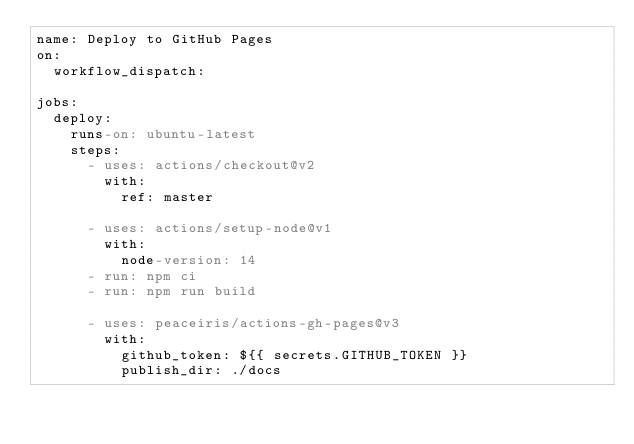Convert code to text. <code><loc_0><loc_0><loc_500><loc_500><_YAML_>name: Deploy to GitHub Pages
on:
  workflow_dispatch:

jobs:
  deploy:
    runs-on: ubuntu-latest
    steps:
      - uses: actions/checkout@v2
        with:
          ref: master

      - uses: actions/setup-node@v1
        with:
          node-version: 14
      - run: npm ci
      - run: npm run build

      - uses: peaceiris/actions-gh-pages@v3
        with:
          github_token: ${{ secrets.GITHUB_TOKEN }}
          publish_dir: ./docs
</code> 